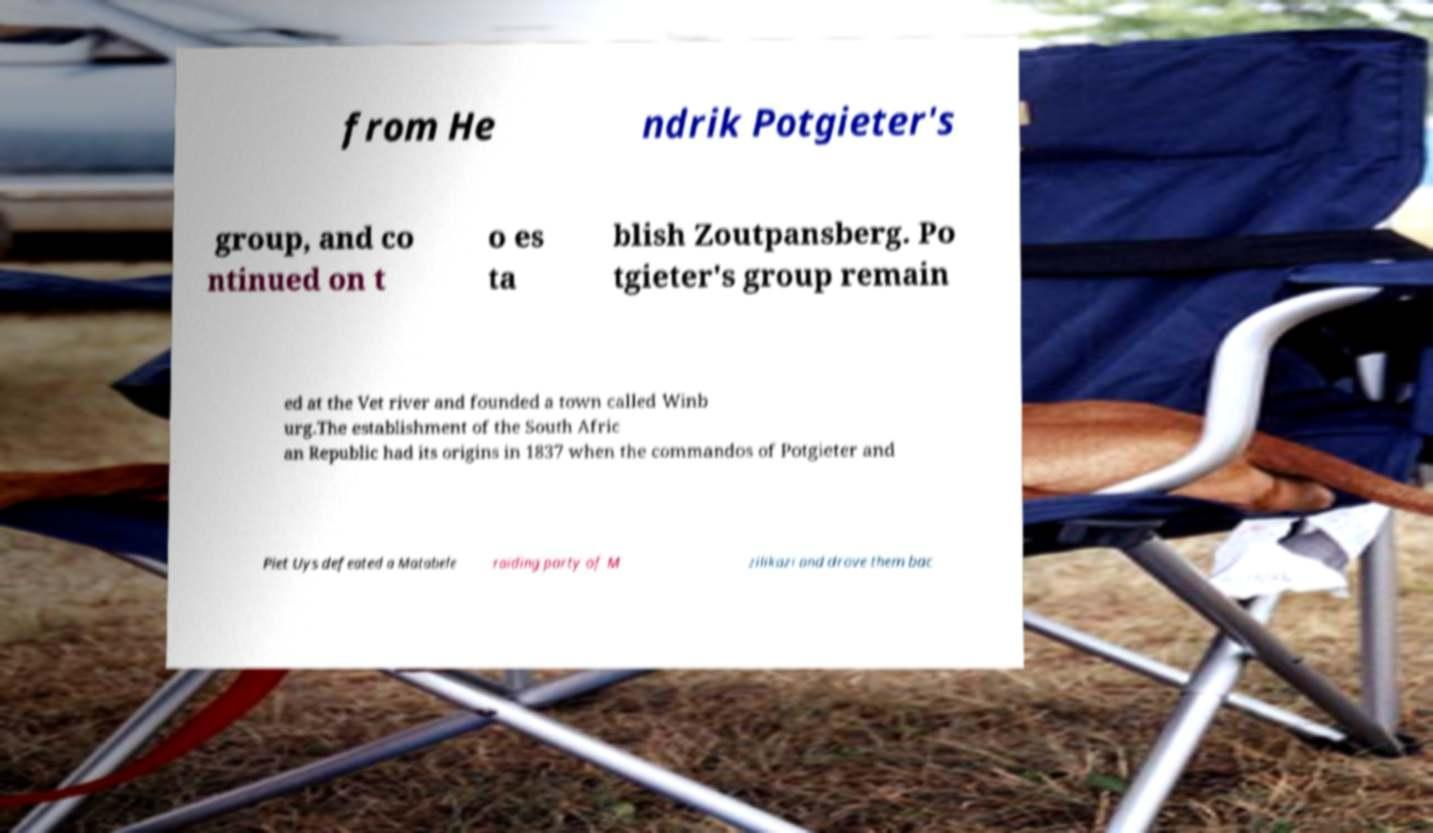Please read and relay the text visible in this image. What does it say? from He ndrik Potgieter's group, and co ntinued on t o es ta blish Zoutpansberg. Po tgieter's group remain ed at the Vet river and founded a town called Winb urg.The establishment of the South Afric an Republic had its origins in 1837 when the commandos of Potgieter and Piet Uys defeated a Matabele raiding party of M zilikazi and drove them bac 